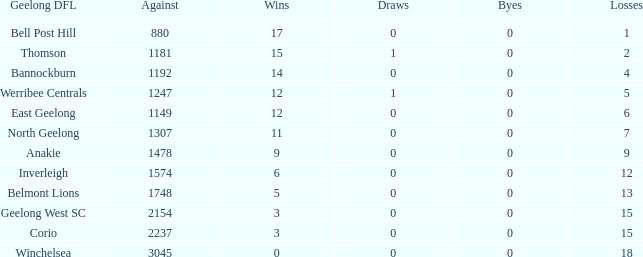What is the lowest number of wins where the byes are less than 0? None. 